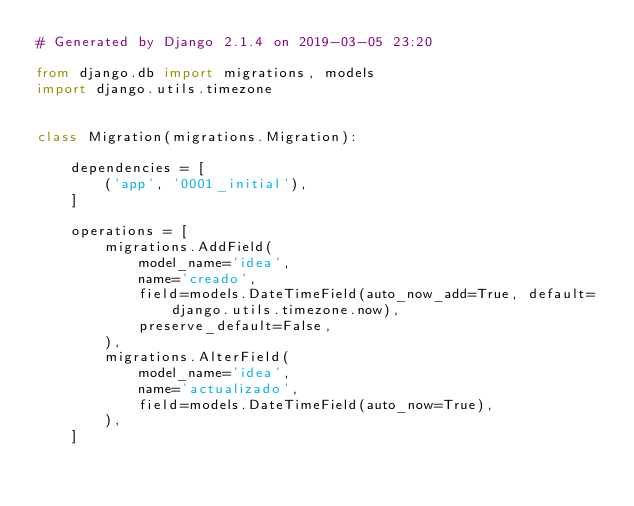Convert code to text. <code><loc_0><loc_0><loc_500><loc_500><_Python_># Generated by Django 2.1.4 on 2019-03-05 23:20

from django.db import migrations, models
import django.utils.timezone


class Migration(migrations.Migration):

    dependencies = [
        ('app', '0001_initial'),
    ]

    operations = [
        migrations.AddField(
            model_name='idea',
            name='creado',
            field=models.DateTimeField(auto_now_add=True, default=django.utils.timezone.now),
            preserve_default=False,
        ),
        migrations.AlterField(
            model_name='idea',
            name='actualizado',
            field=models.DateTimeField(auto_now=True),
        ),
    ]
</code> 